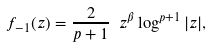<formula> <loc_0><loc_0><loc_500><loc_500>f _ { - 1 } ( z ) = \frac { 2 } { p + 1 } \ z ^ { \beta } \log ^ { p + 1 } | z | ,</formula> 